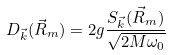<formula> <loc_0><loc_0><loc_500><loc_500>D _ { \vec { k } } ( \vec { R } _ { m } ) = 2 g \frac { S _ { \vec { k } } ( \vec { R } _ { m } ) } { \sqrt { 2 M \omega _ { 0 } } }</formula> 